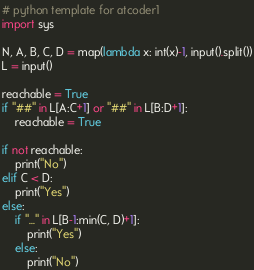Convert code to text. <code><loc_0><loc_0><loc_500><loc_500><_Python_># python template for atcoder1
import sys

N, A, B, C, D = map(lambda x: int(x)-1, input().split())
L = input()

reachable = True
if "##" in L[A:C+1] or "##" in L[B:D+1]:
    reachable = True

if not reachable:
    print("No")
elif C < D:
    print("Yes")
else:
    if "..." in L[B-1:min(C, D)+1]:
        print("Yes")
    else:
        print("No")
</code> 